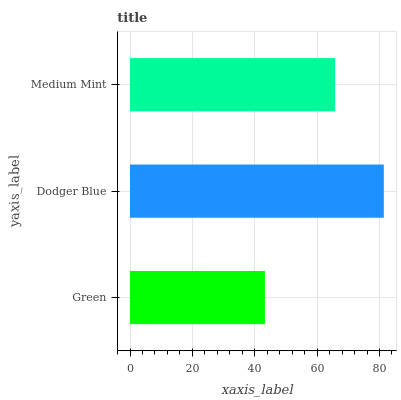Is Green the minimum?
Answer yes or no. Yes. Is Dodger Blue the maximum?
Answer yes or no. Yes. Is Medium Mint the minimum?
Answer yes or no. No. Is Medium Mint the maximum?
Answer yes or no. No. Is Dodger Blue greater than Medium Mint?
Answer yes or no. Yes. Is Medium Mint less than Dodger Blue?
Answer yes or no. Yes. Is Medium Mint greater than Dodger Blue?
Answer yes or no. No. Is Dodger Blue less than Medium Mint?
Answer yes or no. No. Is Medium Mint the high median?
Answer yes or no. Yes. Is Medium Mint the low median?
Answer yes or no. Yes. Is Green the high median?
Answer yes or no. No. Is Green the low median?
Answer yes or no. No. 